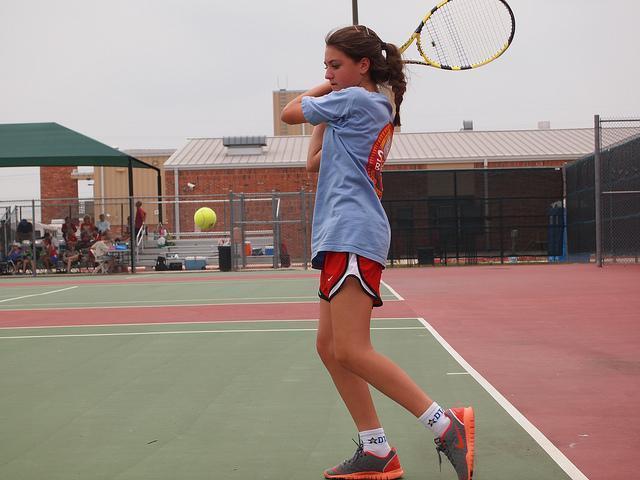How many birds are there?
Give a very brief answer. 0. 